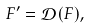Convert formula to latex. <formula><loc_0><loc_0><loc_500><loc_500>F ^ { \prime } = \mathcal { D } ( F ) ,</formula> 